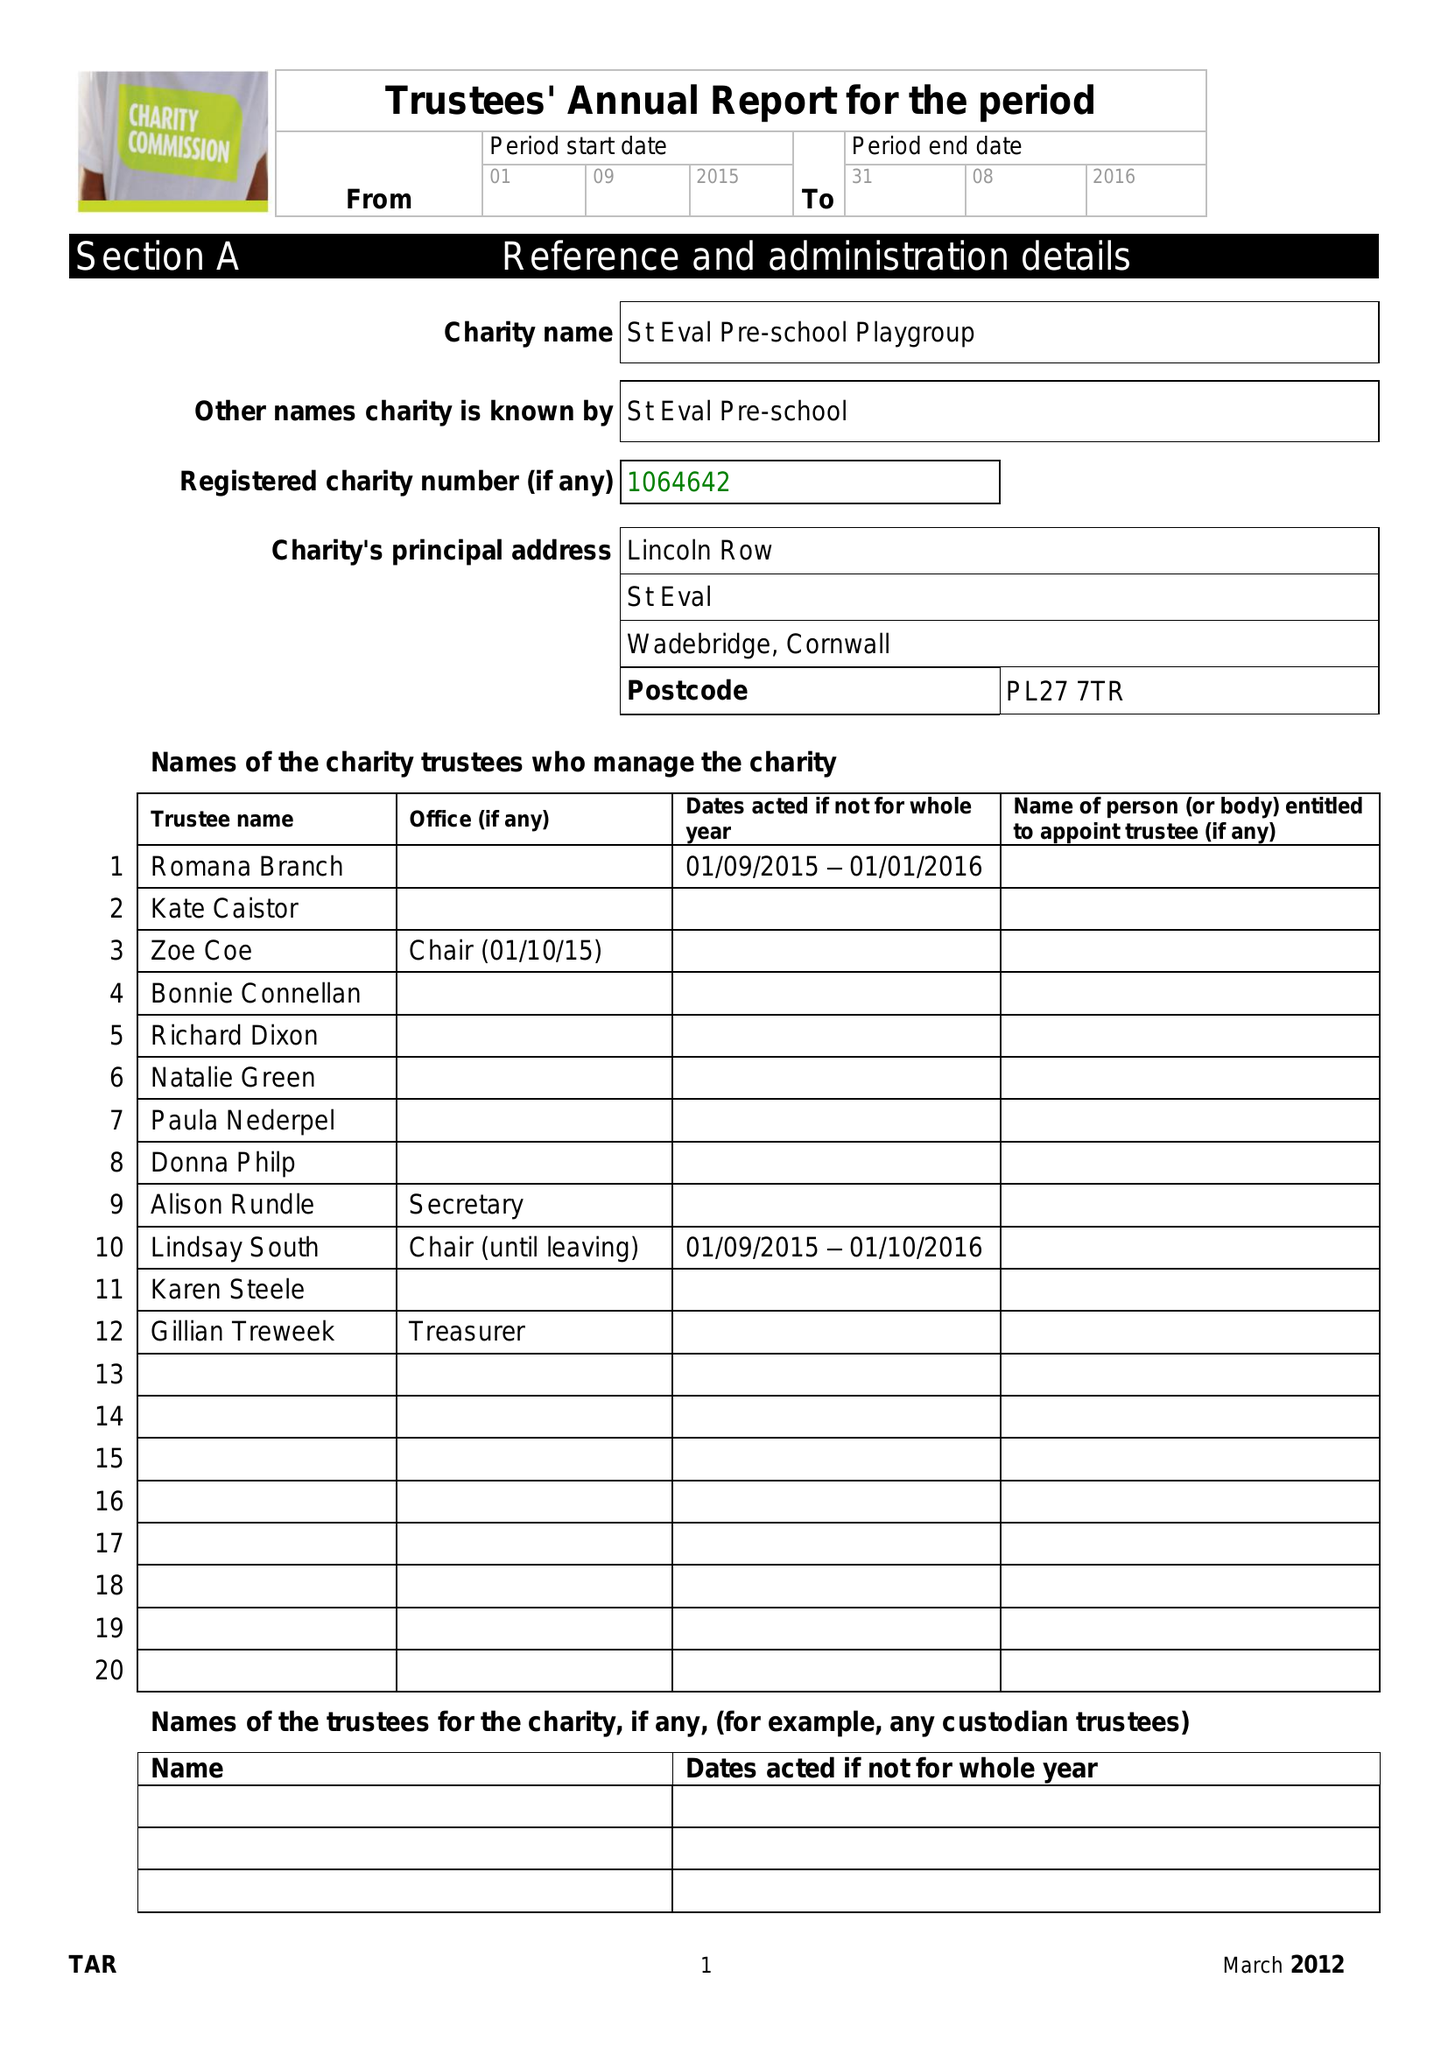What is the value for the report_date?
Answer the question using a single word or phrase. 2016-08-31 